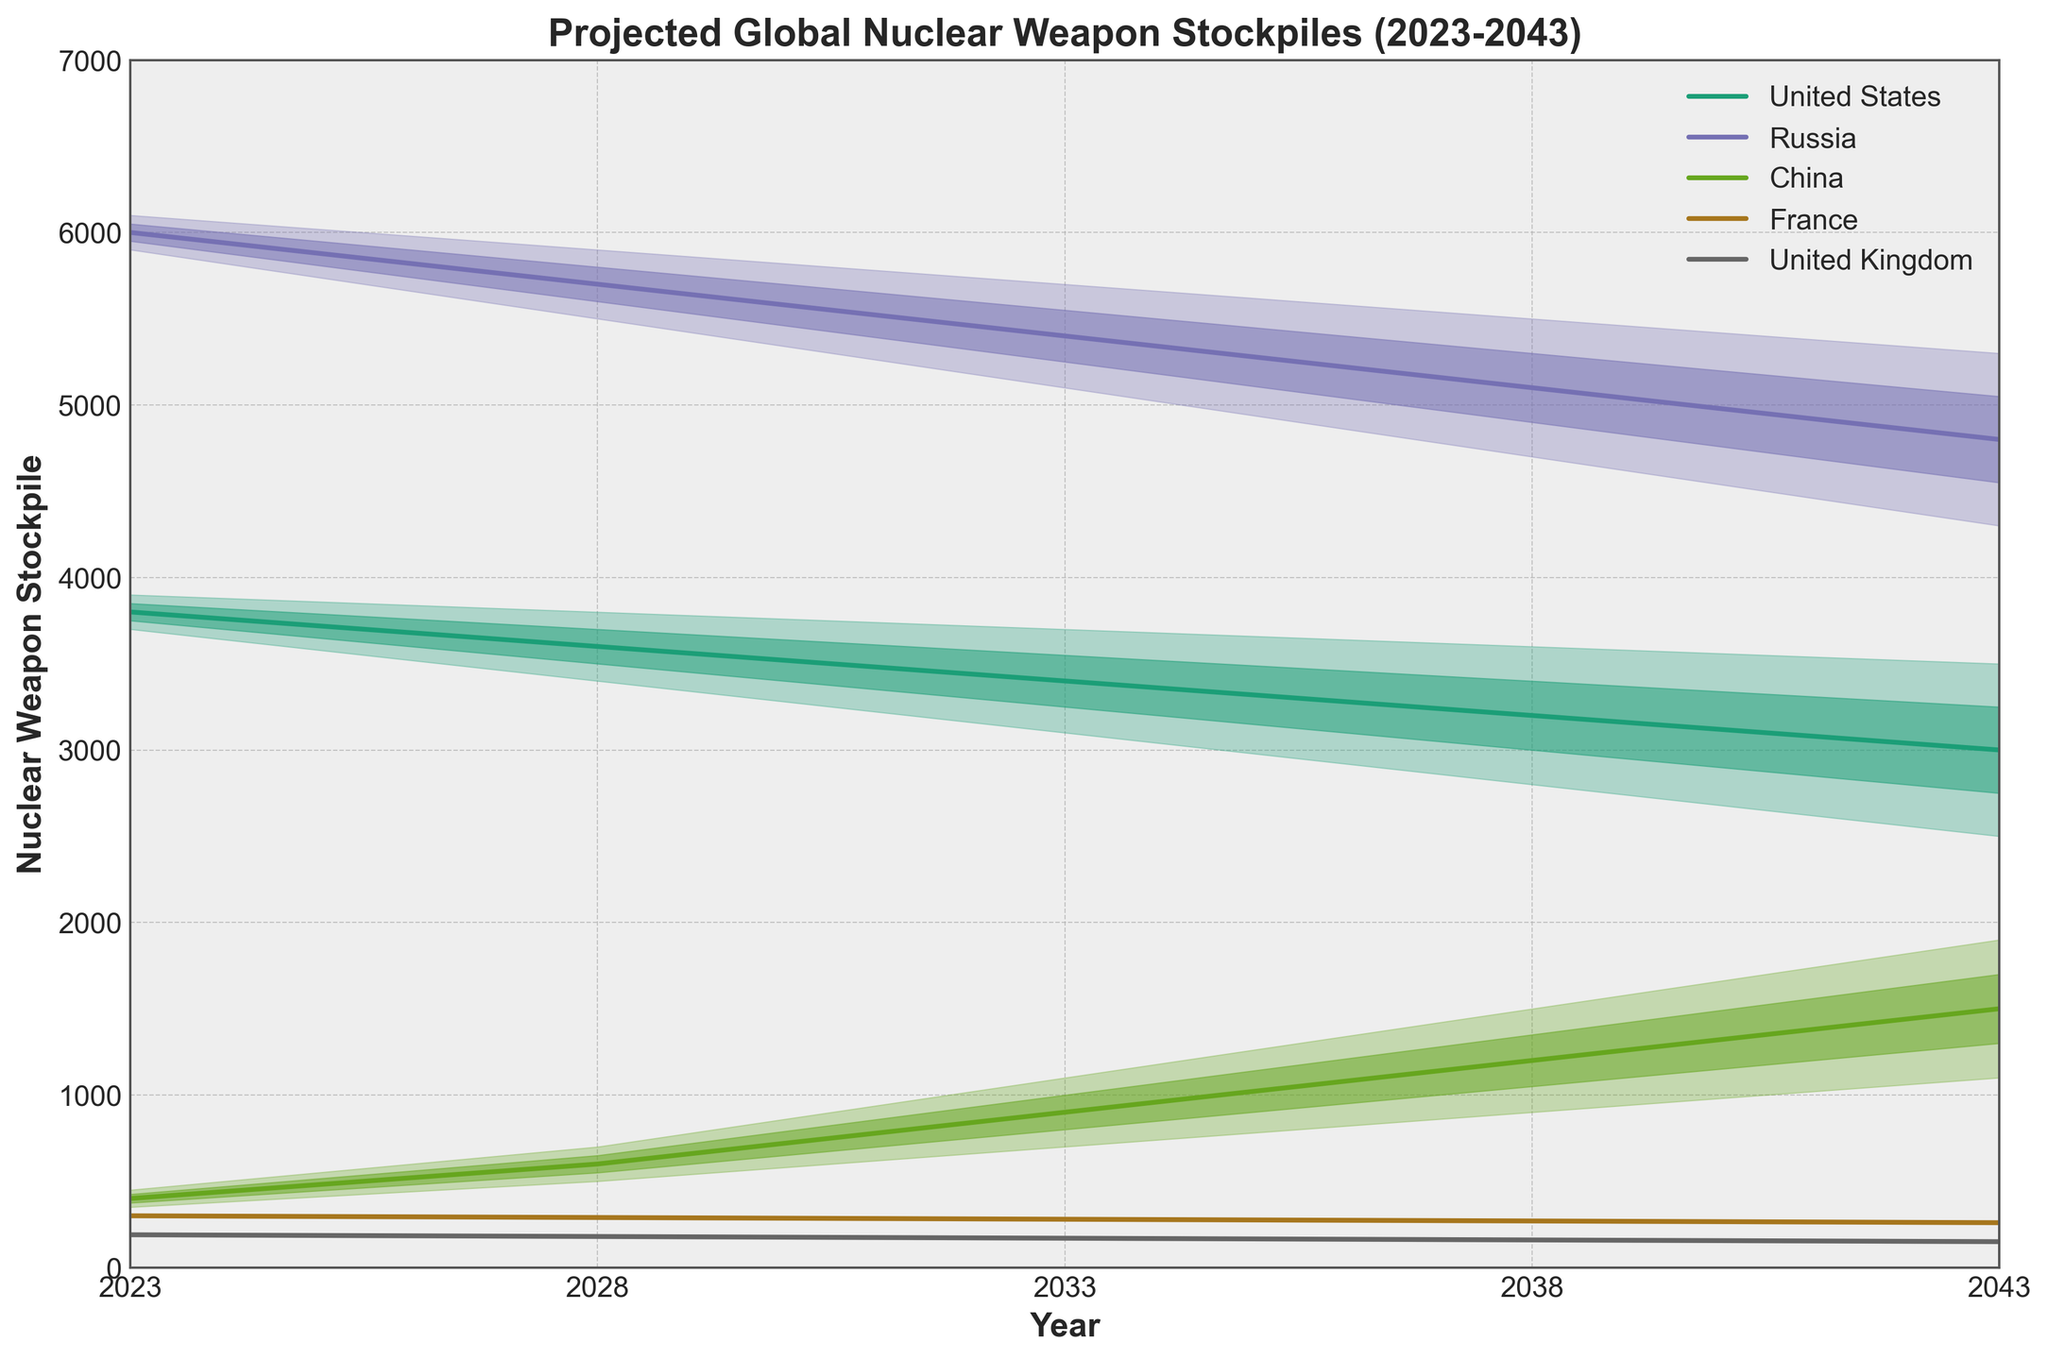What's the title of the figure? The title is displayed at the top of the figure in bold font. It reads "Projected Global Nuclear Weapon Stockpiles (2023-2043)".
Answer: Projected Global Nuclear Weapon Stockpiles (2023-2043) What does the x-axis represent? The x-axis represents the years, ranging from 2023 to 2043. This can be seen at the bottom of the plot where the years are labeled.
Answer: Years Which country has the highest median projected stockpile in 2043? To find this, look at the mid (median) value for each country in 2043. Russia has the highest median value at 4800, as shown by the central line within the band.
Answer: Russia By how much is China's high projection in 2043 greater than its high projection in 2023? China's high projection in 2043 is 1900, and in 2023 it is 450. Subtracting these values gives 1900 - 450 = 1450.
Answer: 1450 Which country shows the greatest increase in its high projection between 2023 and 2043? Calculate the increase in high values for each country from 2023 to 2043. China increases from 450 to 1900, a total increase of 1450, which is the greatest compared to the other countries.
Answer: China How does the projected stockpile of the United States in 2038 compare to that in 2043 at the mid level? Compare the mid values for the United States in 2038 and 2043. In 2038, the mid value is 3200, and in 2043, it's 3000. The stockpile is 200 units lower in 2043.
Answer: 200 units lower in 2043 What is the range of France's projected stockpile in 2033? The range is determined by subtracting the low value from the high value. In 2033, France's low value is 270, and the high value is 290. The range is 290 - 270 = 20.
Answer: 20 Compare the projected stockpile range of Russia and the United Kingdom in 2043. Which is larger? The range for Russia in 2043 is 5300 - 4300 = 1000. For the United Kingdom, it's 160 - 140 = 20. Russia's range is significantly larger.
Answer: Russia Which country has the most stable projections (least variation) over the years? Look for the country with the smallest change between its low and high projections. France's projections remain relatively stable compared to others, with narrow bands throughout the years.
Answer: France 